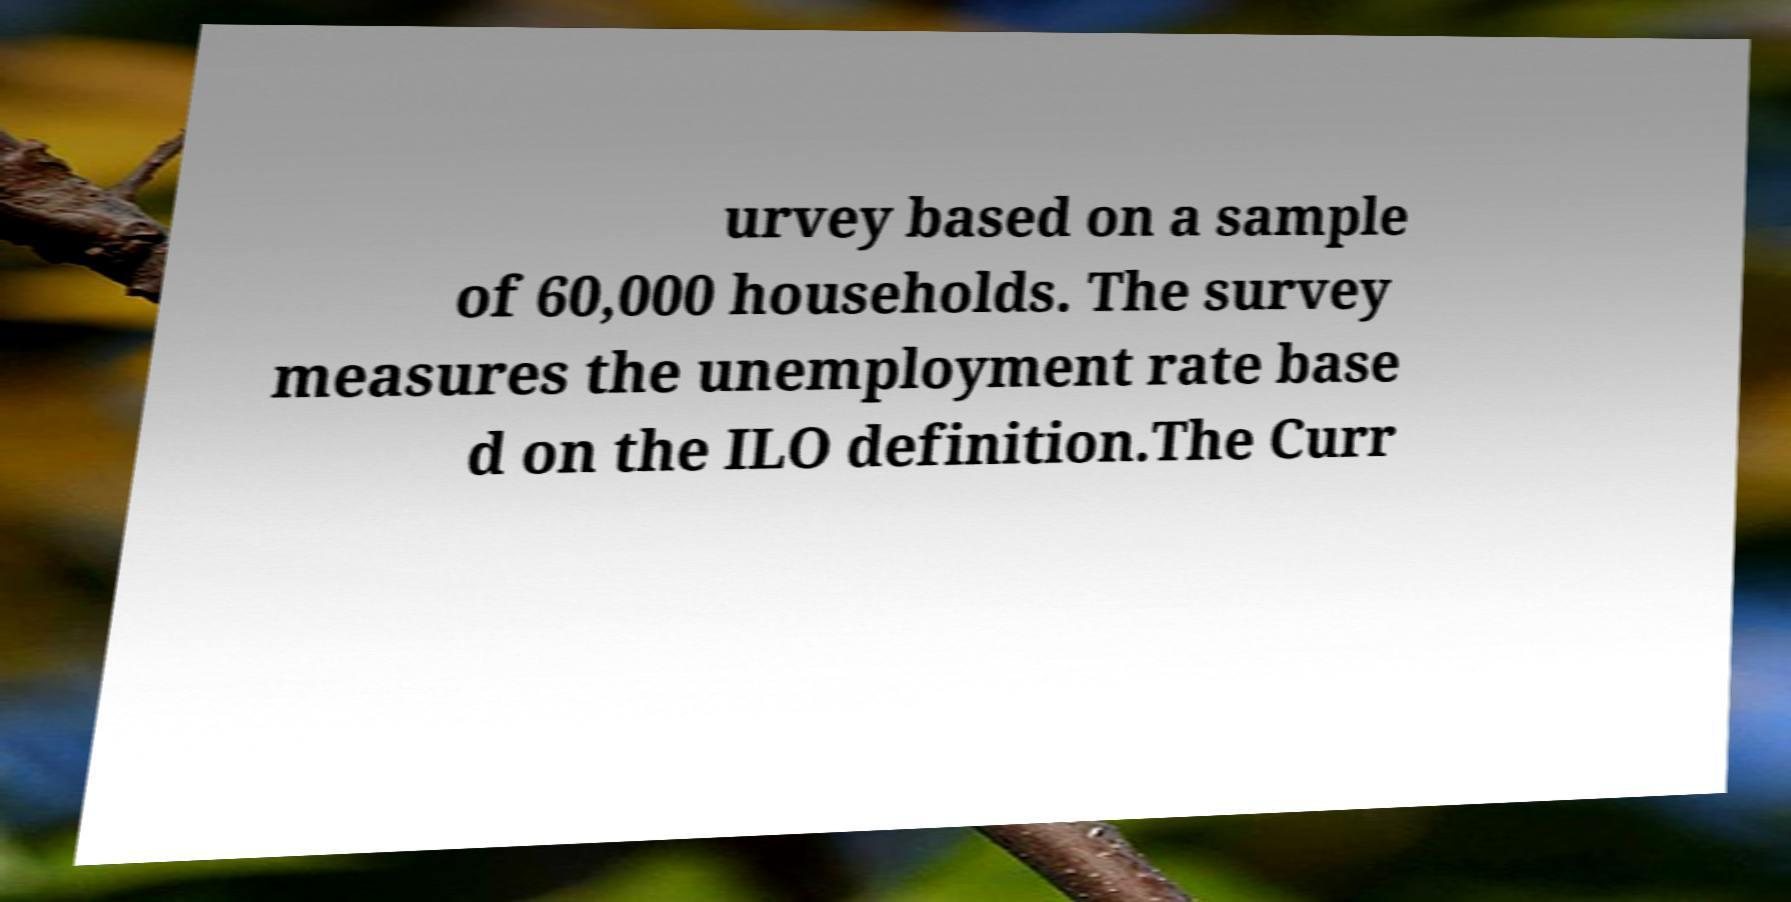I need the written content from this picture converted into text. Can you do that? urvey based on a sample of 60,000 households. The survey measures the unemployment rate base d on the ILO definition.The Curr 